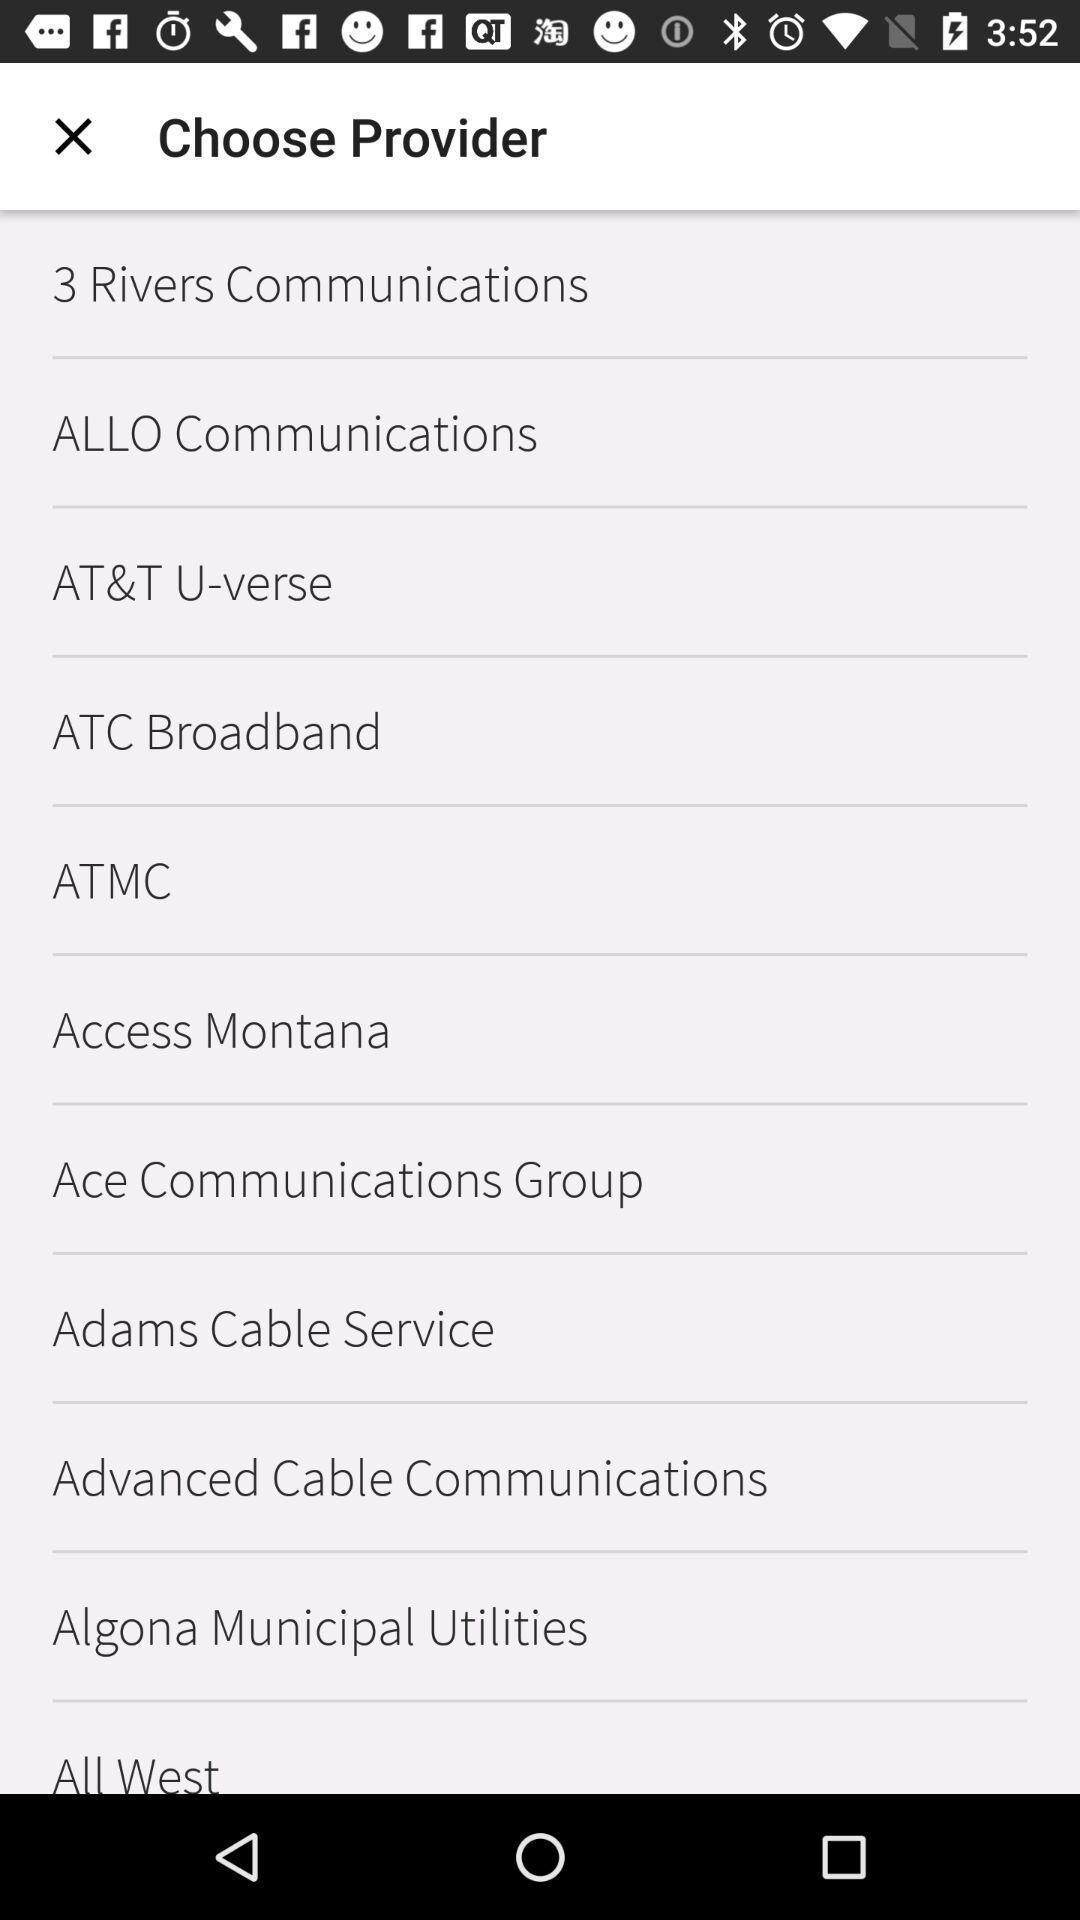Describe this image in words. Screen shows list of choose provider. 